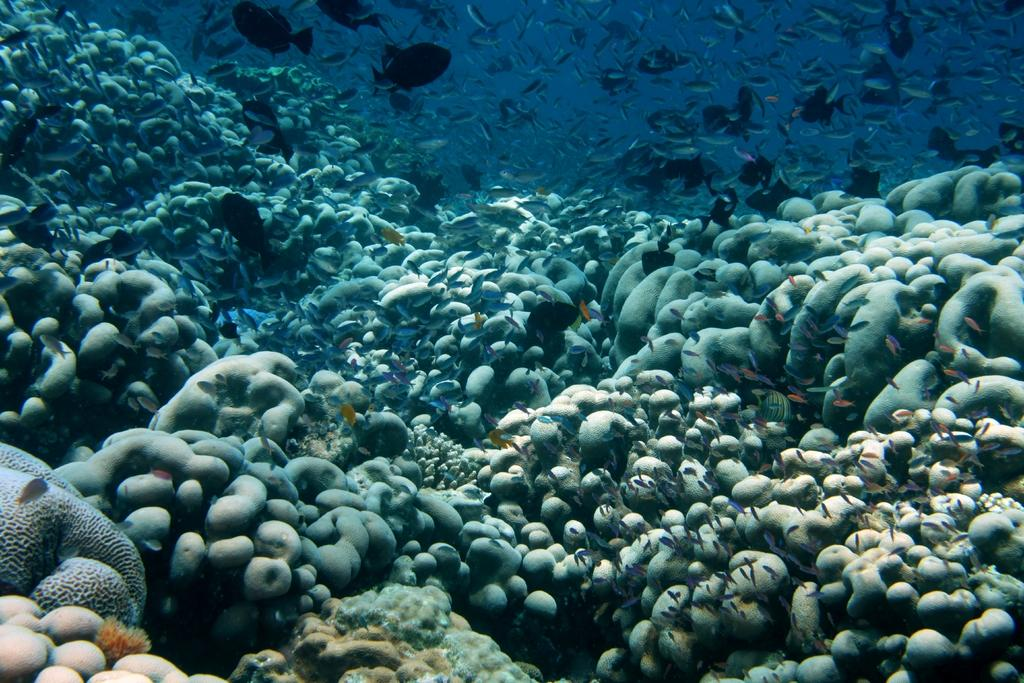Where was the image taken? The image was taken underwater. What types of creatures can be seen in the image? There are marine species visible in the image. What type of nerve can be seen in the image? There are no nerves present in the image, as it features marine species underwater. 